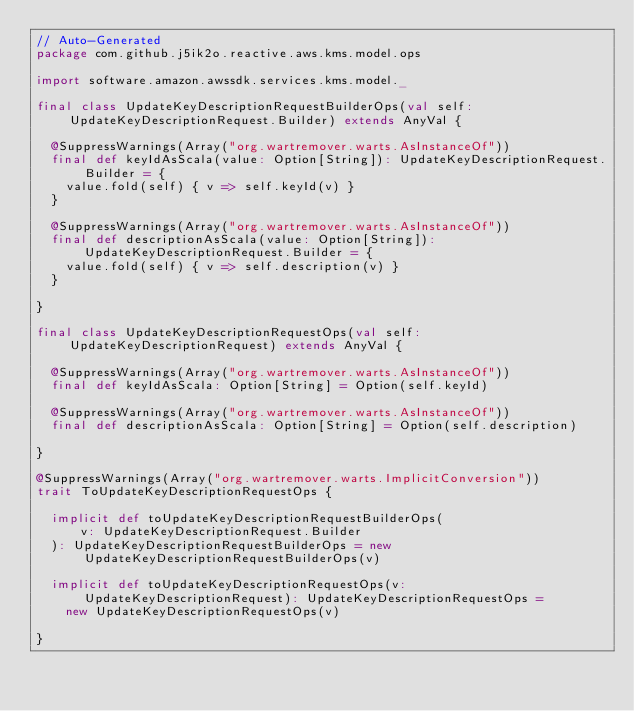Convert code to text. <code><loc_0><loc_0><loc_500><loc_500><_Scala_>// Auto-Generated
package com.github.j5ik2o.reactive.aws.kms.model.ops

import software.amazon.awssdk.services.kms.model._

final class UpdateKeyDescriptionRequestBuilderOps(val self: UpdateKeyDescriptionRequest.Builder) extends AnyVal {

  @SuppressWarnings(Array("org.wartremover.warts.AsInstanceOf"))
  final def keyIdAsScala(value: Option[String]): UpdateKeyDescriptionRequest.Builder = {
    value.fold(self) { v => self.keyId(v) }
  }

  @SuppressWarnings(Array("org.wartremover.warts.AsInstanceOf"))
  final def descriptionAsScala(value: Option[String]): UpdateKeyDescriptionRequest.Builder = {
    value.fold(self) { v => self.description(v) }
  }

}

final class UpdateKeyDescriptionRequestOps(val self: UpdateKeyDescriptionRequest) extends AnyVal {

  @SuppressWarnings(Array("org.wartremover.warts.AsInstanceOf"))
  final def keyIdAsScala: Option[String] = Option(self.keyId)

  @SuppressWarnings(Array("org.wartremover.warts.AsInstanceOf"))
  final def descriptionAsScala: Option[String] = Option(self.description)

}

@SuppressWarnings(Array("org.wartremover.warts.ImplicitConversion"))
trait ToUpdateKeyDescriptionRequestOps {

  implicit def toUpdateKeyDescriptionRequestBuilderOps(
      v: UpdateKeyDescriptionRequest.Builder
  ): UpdateKeyDescriptionRequestBuilderOps = new UpdateKeyDescriptionRequestBuilderOps(v)

  implicit def toUpdateKeyDescriptionRequestOps(v: UpdateKeyDescriptionRequest): UpdateKeyDescriptionRequestOps =
    new UpdateKeyDescriptionRequestOps(v)

}
</code> 